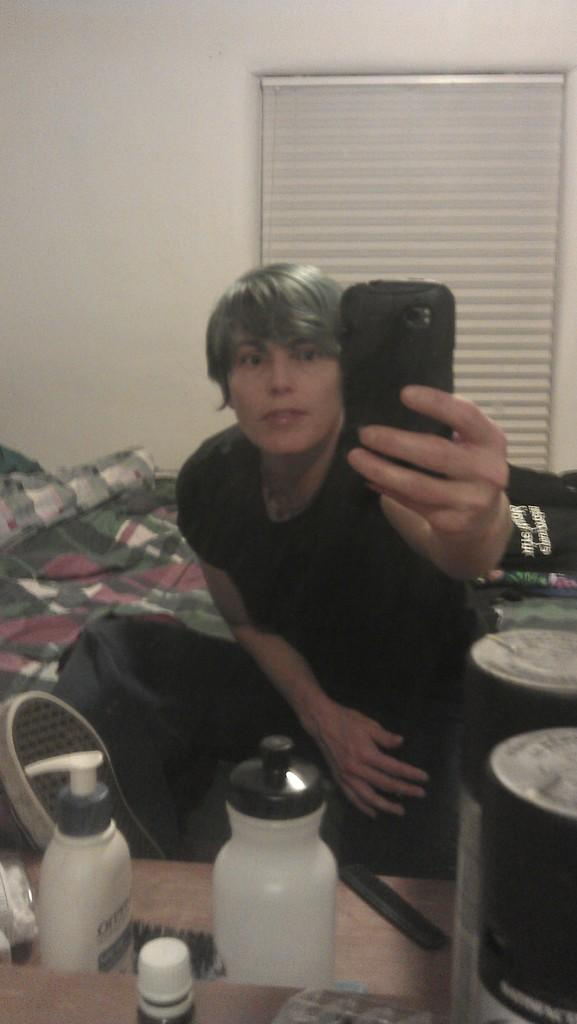What is the man in the image doing? The man is sitting in the image. What is the man holding in the image? The man is holding a mobile in the image. What other objects can be seen in the image besides the man and the mobile? There are bottles, a comb, and other objects in the image. What can be seen in the background of the image? There is cloth, a wall, and a window blind visible in the background of the image. How many houses are visible in the image? There is no house visible in the image; only a man, objects, and background elements are present. What type of sponge is being used by the man in the image? There is no sponge present in the image. 